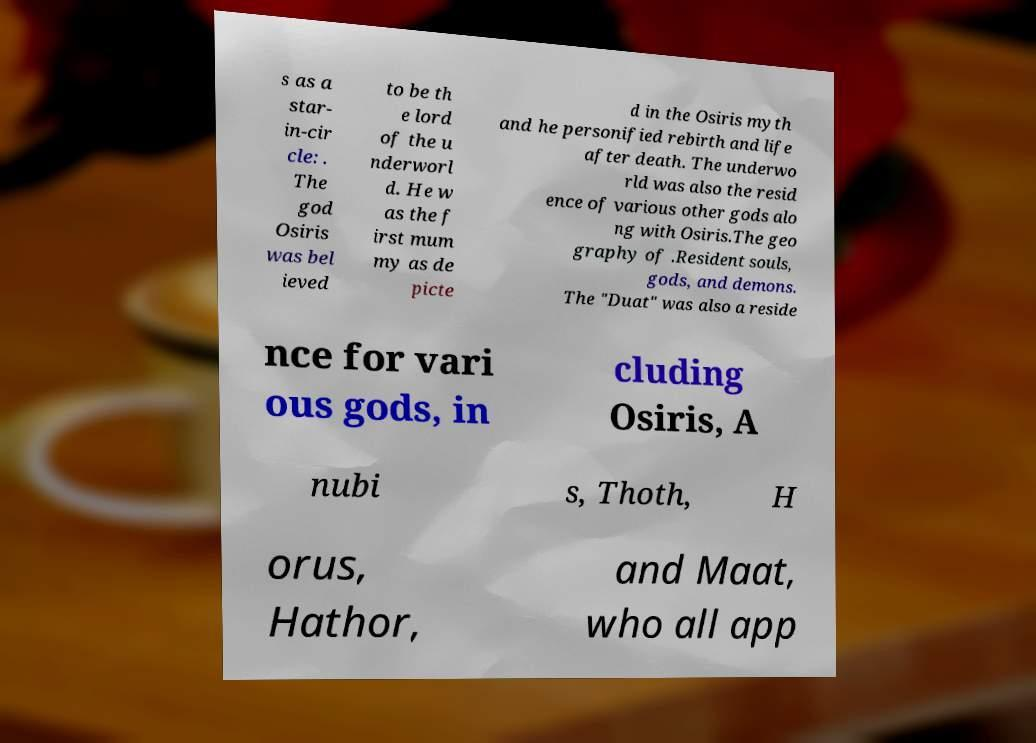What messages or text are displayed in this image? I need them in a readable, typed format. s as a star- in-cir cle: . The god Osiris was bel ieved to be th e lord of the u nderworl d. He w as the f irst mum my as de picte d in the Osiris myth and he personified rebirth and life after death. The underwo rld was also the resid ence of various other gods alo ng with Osiris.The geo graphy of .Resident souls, gods, and demons. The "Duat" was also a reside nce for vari ous gods, in cluding Osiris, A nubi s, Thoth, H orus, Hathor, and Maat, who all app 